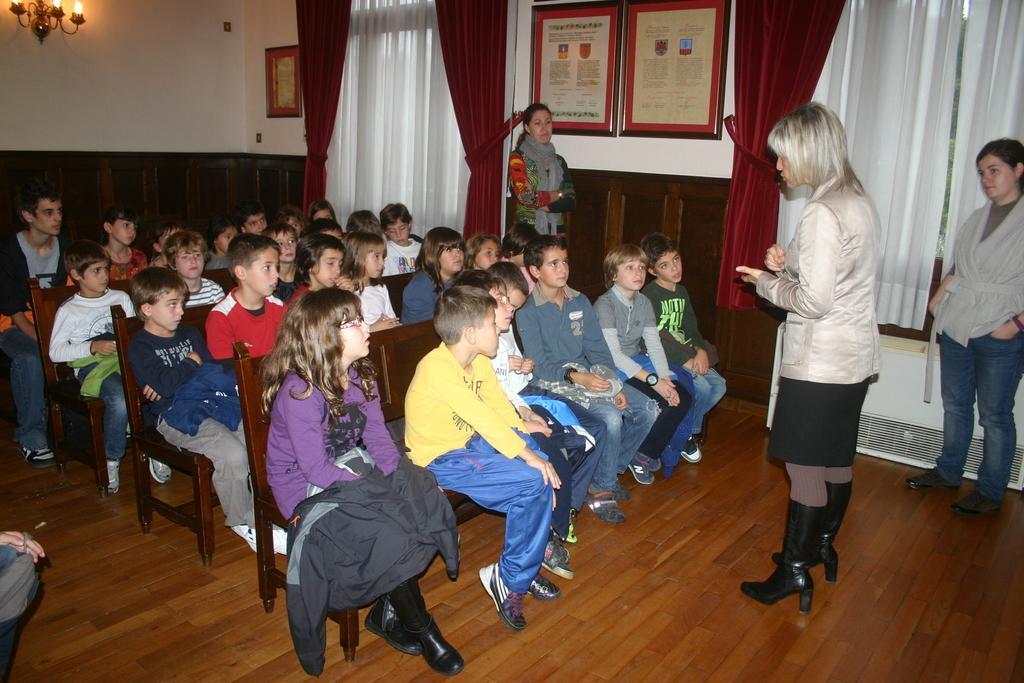In one or two sentences, can you explain what this image depicts? This is an inside view of a room. On the right side there are two women standing on the floor. One woman is speaking by looking at the children who are sitting on the benches. The children also looking at this woman. In the background there is a wall on which few frames are attached and also I can see the curtains the windows. In the top left there are few candles. In the background there is another woman standing beside the wall. 